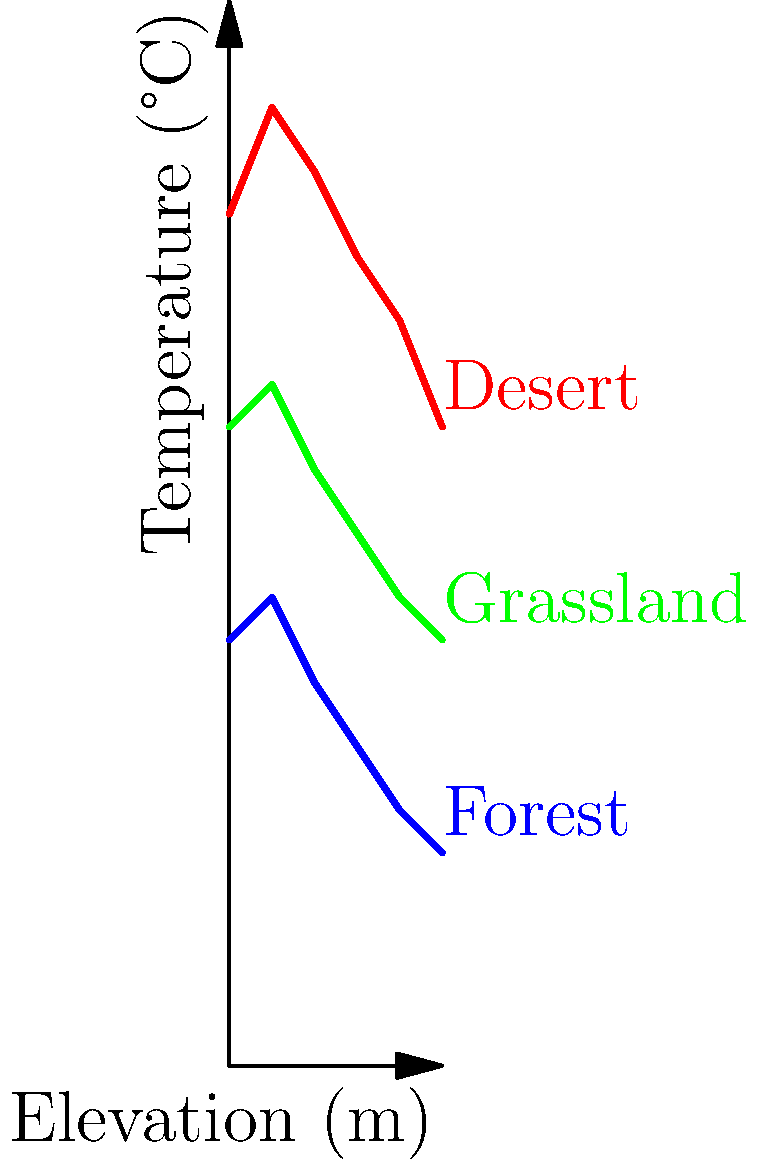The graph shows the relationship between elevation and temperature for three major habitat types in Middle Eastern ecosystems. Which habitat type exhibits the greatest change in temperature as elevation increases, and what topological property does this represent? To answer this question, we need to analyze the slopes of the lines representing each habitat type:

1. Desert (red line): 
   - Starts at about 40°C at 0m elevation
   - Ends at about 30°C at 10m elevation
   - Temperature change: approximately 10°C over 10m

2. Grassland (green line):
   - Starts at about 30°C at 0m elevation
   - Ends at about 20°C at 10m elevation
   - Temperature change: approximately 10°C over 10m

3. Forest (blue line):
   - Starts at about 20°C at 0m elevation
   - Ends at about 10°C at 10m elevation
   - Temperature change: approximately 10°C over 10m

All three habitat types show a similar overall temperature change of about 10°C over the 10m elevation increase. However, the desert habitat line has the steepest slope, particularly in the first half of the elevation range.

In topological terms, the steepness of the line represents the rate of change or gradient of the temperature with respect to elevation. This is related to the concept of the first derivative in calculus, which measures the instantaneous rate of change of a function.

The desert habitat's steeper slope indicates a more rapid temperature change with elevation, especially at lower elevations. This could be due to factors such as less vegetation cover and more direct sun exposure in desert environments, leading to more dramatic temperature fluctuations.

The topological property represented by this steeper slope is the gradient or rate of change of the temperature function with respect to elevation.
Answer: Desert habitat; gradient (rate of change) 